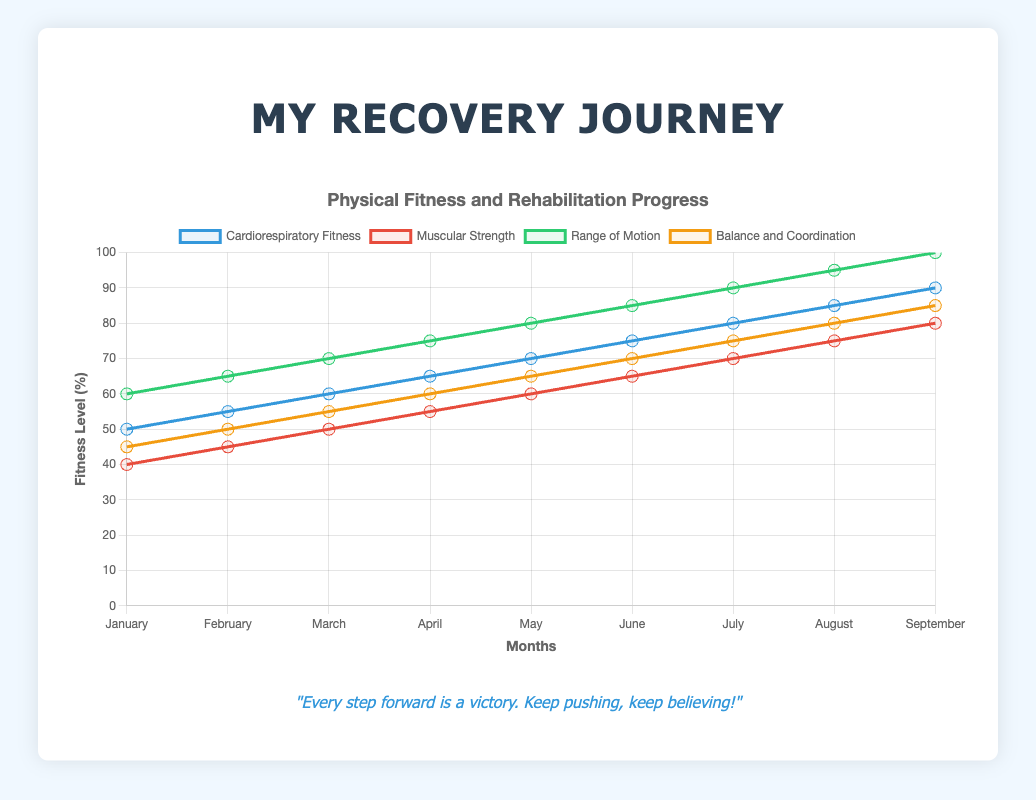What is the cardiorespiratory fitness level in June? On the line plot, find the data point for Cardiorespiratory Fitness corresponding to the month of June. The value is 75.
Answer: 75 Which month shows the highest improvement in muscular strength compared to the previous month? Calculate the month-to-month difference in muscular strength. February to March (45 to 50) shows a difference of 5, March to April (50 to 55) is 5, etc. The highest difference is from February to March.
Answer: March What is the average range of motion for the months of January, February, and March? Add the range of motion values for January, February, and March (60, 65, 70) and divide by 3. The calculation is (60 + 65 + 70) / 3 = 65.
Answer: 65 Compared to July, how much lower is the balance and coordination level in March? Subtract the balance and coordination value in March from July (75 - 55). The difference is 20.
Answer: 20 Which attribute shows the steepest increase from January to September? Observe the slopes of all attributes from January to September. Range of Motion goes from 60 to 100, an increase of 40, which is the highest among all attributes.
Answer: Range of Motion In which month do both cardiorespiratory fitness and muscular strength exceed 70? Find the month where both values are greater than 70 on the plot. For Cardiorespiratory Fitness and Muscular Strength, this is true in August (85 and 75, respectively).
Answer: August What is the difference between the highest and lowest balance and coordination values during the recorded period? Subtract the lowest balance and coordination value (January, 45) from the highest value (September, 85). The difference is 85 - 45 = 40.
Answer: 40 From January to September, what is the total increase in balance and coordination? Subtract the value in January from the value in September for balance and coordination. The calculation is 85 - 45 = 40.
Answer: 40 Which two attributes have the most similar trends throughout the months? Compare the slopes and data points of each attribute from January to September. Cardiorespiratory Fitness and Range of Motion follow a closely similar increasing trend.
Answer: Cardiorespiratory Fitness and Range of Motion When does the balance and coordination first reach 50? Look at the balance and coordination line plot and identify the first month when the value reaches 50. It reaches 50 in February.
Answer: February 